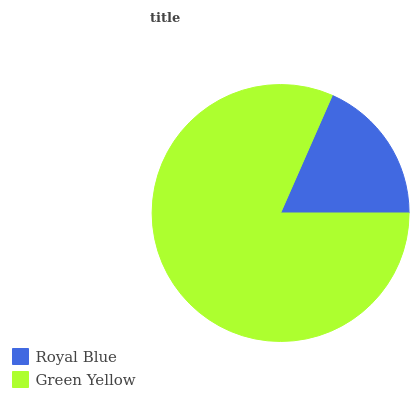Is Royal Blue the minimum?
Answer yes or no. Yes. Is Green Yellow the maximum?
Answer yes or no. Yes. Is Green Yellow the minimum?
Answer yes or no. No. Is Green Yellow greater than Royal Blue?
Answer yes or no. Yes. Is Royal Blue less than Green Yellow?
Answer yes or no. Yes. Is Royal Blue greater than Green Yellow?
Answer yes or no. No. Is Green Yellow less than Royal Blue?
Answer yes or no. No. Is Green Yellow the high median?
Answer yes or no. Yes. Is Royal Blue the low median?
Answer yes or no. Yes. Is Royal Blue the high median?
Answer yes or no. No. Is Green Yellow the low median?
Answer yes or no. No. 